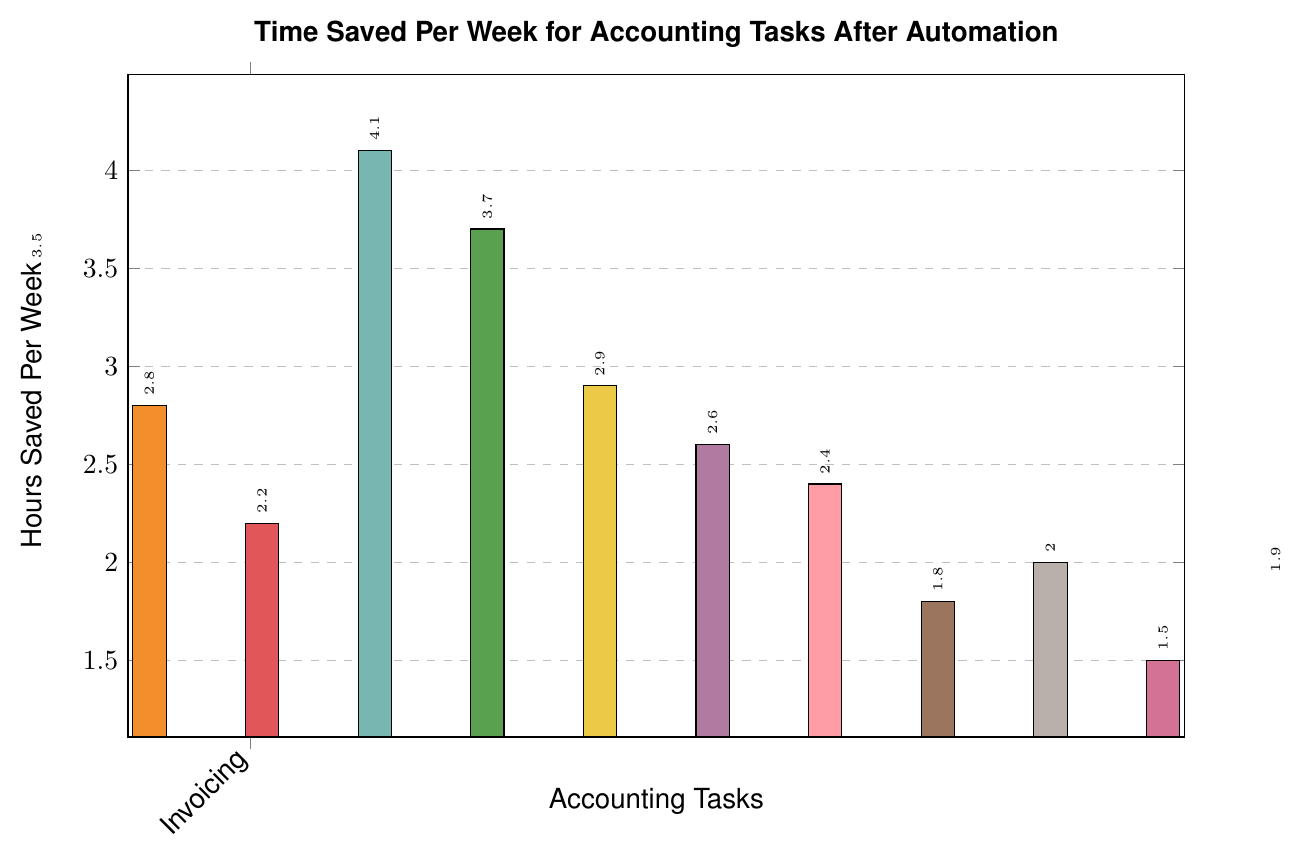What's the task with the highest time saved per week after automation? By looking at the figure, we can identify the highest bar, which represents the task with the most hours saved per week.
Answer: Payroll Processing What's the total time saved for the tasks Invoicing and Financial Reporting combined? Sum the hours saved for Invoicing (3.5) and Financial Reporting (3.7): 3.5 + 3.7 = 7.2
Answer: 7.2 Which task has a similar time saved to Tax Preparation? By comparing the heights of the bars, we can see that Financial Reporting has a similar height and hence a similar time saved to Tax Preparation.
Answer: Financial Reporting How much more time is saved in Payroll Processing compared to Cash Flow Analysis? Subtract the hours saved for Cash Flow Analysis (1.5) from the hours saved for Payroll Processing (4.1): 4.1 - 1.5 = 2.6
Answer: 2.6 What's the average time saved per week across all tasks? Sum all the hours and divide by the number of tasks. Sum: 3.5+2.8+2.2+4.1+3.7+2.9+2.6+2.4+1.8+2.0+1.5+1.9 = 33.4. Divide by 12 tasks: 33.4 / 12 ≈ 2.78
Answer: 2.78 Is Expense Tracking time saved greater than Accounts Receivable? By comparing the heights of the bars, we can see that Expense Tracking (2.2) is less than Accounts Receivable (2.4).
Answer: No Which two tasks have the smallest time saved per week? By observing the shortest bars, we can see that Cash Flow Analysis (1.5) and Inventory Management (1.8) have the smallest time saved per week.
Answer: Cash Flow Analysis and Inventory Management What's the difference in hours saved between Bank Reconciliation and Audit Preparation? Subtract the hours saved for Audit Preparation (1.9) from Bank Reconciliation (2.8): 2.8 - 1.9 = 0.9
Answer: 0.9 Is there any task with exactly 2 hours saved per week? By looking at the figure, we can identify that Budget Forecasting has a bar labeled with exactly 2 hours saved per week.
Answer: Budget Forecasting 